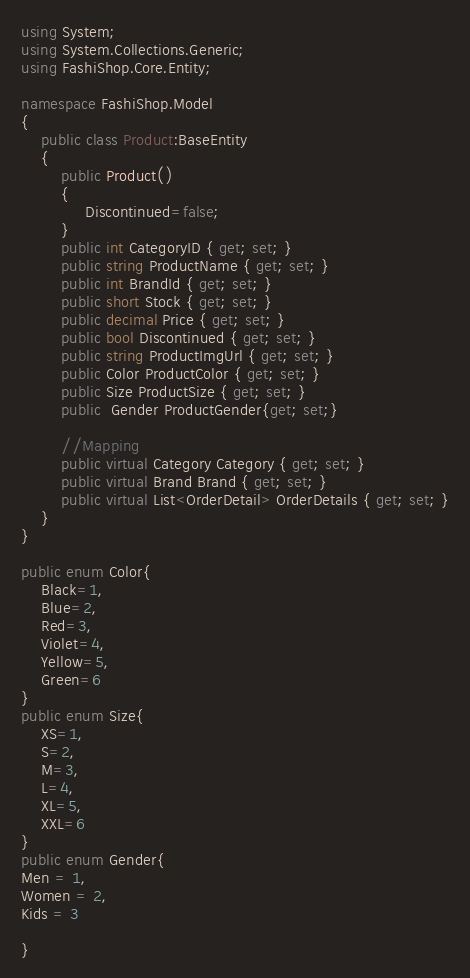Convert code to text. <code><loc_0><loc_0><loc_500><loc_500><_C#_>using System;
using System.Collections.Generic;
using FashiShop.Core.Entity;

namespace FashiShop.Model
{
    public class Product:BaseEntity
    {
        public Product()
        {
             Discontinued=false;
        }
        public int CategoryID { get; set; }
        public string ProductName { get; set; }
        public int BrandId { get; set; }
        public short Stock { get; set; }
        public decimal Price { get; set; }
        public bool Discontinued { get; set; }
        public string ProductImgUrl { get; set; }
        public Color ProductColor { get; set; }
        public Size ProductSize { get; set; }
        public  Gender ProductGender{get; set;}

        //Mapping
        public virtual Category Category { get; set; }
        public virtual Brand Brand { get; set; }
        public virtual List<OrderDetail> OrderDetails { get; set; }
    }
}

public enum Color{
    Black=1,
    Blue=2,
    Red=3,
    Violet=4,
    Yellow=5,
    Green=6
}
public enum Size{
    XS=1,
    S=2,
    M=3,
    L=4,
    XL=5,
    XXL=6
}
public enum Gender{
Men = 1,
Women = 2,
Kids = 3

}</code> 